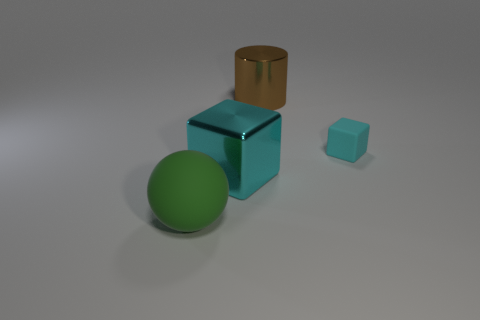How many large things are rubber objects or green matte balls?
Offer a terse response. 1. How big is the metal cylinder?
Provide a short and direct response. Large. Is there anything else that is made of the same material as the tiny cyan block?
Give a very brief answer. Yes. What number of rubber cubes are on the left side of the big brown shiny cylinder?
Make the answer very short. 0. What size is the metal thing that is the same shape as the cyan rubber object?
Keep it short and to the point. Large. There is a thing that is both right of the large green thing and left of the large cylinder; what size is it?
Provide a short and direct response. Large. Is the color of the large block the same as the large thing that is to the right of the big cyan metal thing?
Make the answer very short. No. What number of gray objects are tiny blocks or cylinders?
Offer a very short reply. 0. There is a large green thing; what shape is it?
Your response must be concise. Sphere. How many other things are the same shape as the cyan matte thing?
Keep it short and to the point. 1. 